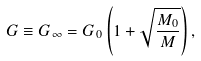Convert formula to latex. <formula><loc_0><loc_0><loc_500><loc_500>G \equiv G _ { \infty } = G _ { 0 } \left ( 1 + \sqrt { \frac { M _ { 0 } } { M } } \right ) ,</formula> 